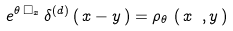<formula> <loc_0><loc_0><loc_500><loc_500>e ^ { \theta \, \Box _ { x } } \, \delta ^ { ( d ) } \left ( \, x - y \, \right ) = \rho _ { \theta } \, \left ( \, x \ , y \, \right )</formula> 